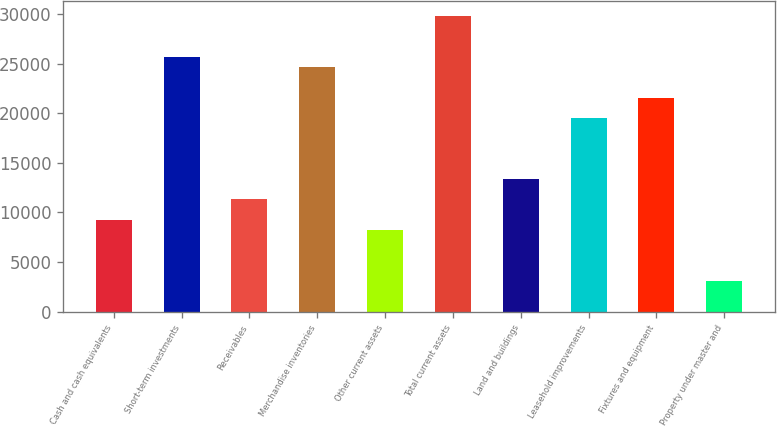<chart> <loc_0><loc_0><loc_500><loc_500><bar_chart><fcel>Cash and cash equivalents<fcel>Short-term investments<fcel>Receivables<fcel>Merchandise inventories<fcel>Other current assets<fcel>Total current assets<fcel>Land and buildings<fcel>Leasehold improvements<fcel>Fixtures and equipment<fcel>Property under master and<nl><fcel>9268.6<fcel>25675<fcel>11319.4<fcel>24649.6<fcel>8243.2<fcel>29776.6<fcel>13370.2<fcel>19522.6<fcel>21573.4<fcel>3116.2<nl></chart> 